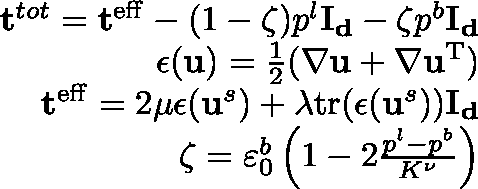<formula> <loc_0><loc_0><loc_500><loc_500>\begin{array} { r } { t ^ { t o t } = t ^ { e f f } - ( 1 - \zeta ) p ^ { l } I _ { d } - \zeta p ^ { b } I _ { d } } \\ { \epsilon ( u ) = \frac { 1 } { 2 } ( \nabla u + \nabla u ^ { T } ) } \\ { t ^ { e f f } = 2 \mu \epsilon ( u ^ { s } ) + \lambda t r ( \epsilon ( u ^ { s } ) ) I _ { d } } \\ { \zeta = \varepsilon _ { 0 } ^ { b } \left ( 1 - 2 \frac { p ^ { l } - p ^ { b } } { K ^ { \nu } } \right ) } \end{array}</formula> 